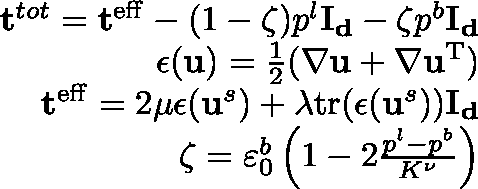<formula> <loc_0><loc_0><loc_500><loc_500>\begin{array} { r } { t ^ { t o t } = t ^ { e f f } - ( 1 - \zeta ) p ^ { l } I _ { d } - \zeta p ^ { b } I _ { d } } \\ { \epsilon ( u ) = \frac { 1 } { 2 } ( \nabla u + \nabla u ^ { T } ) } \\ { t ^ { e f f } = 2 \mu \epsilon ( u ^ { s } ) + \lambda t r ( \epsilon ( u ^ { s } ) ) I _ { d } } \\ { \zeta = \varepsilon _ { 0 } ^ { b } \left ( 1 - 2 \frac { p ^ { l } - p ^ { b } } { K ^ { \nu } } \right ) } \end{array}</formula> 